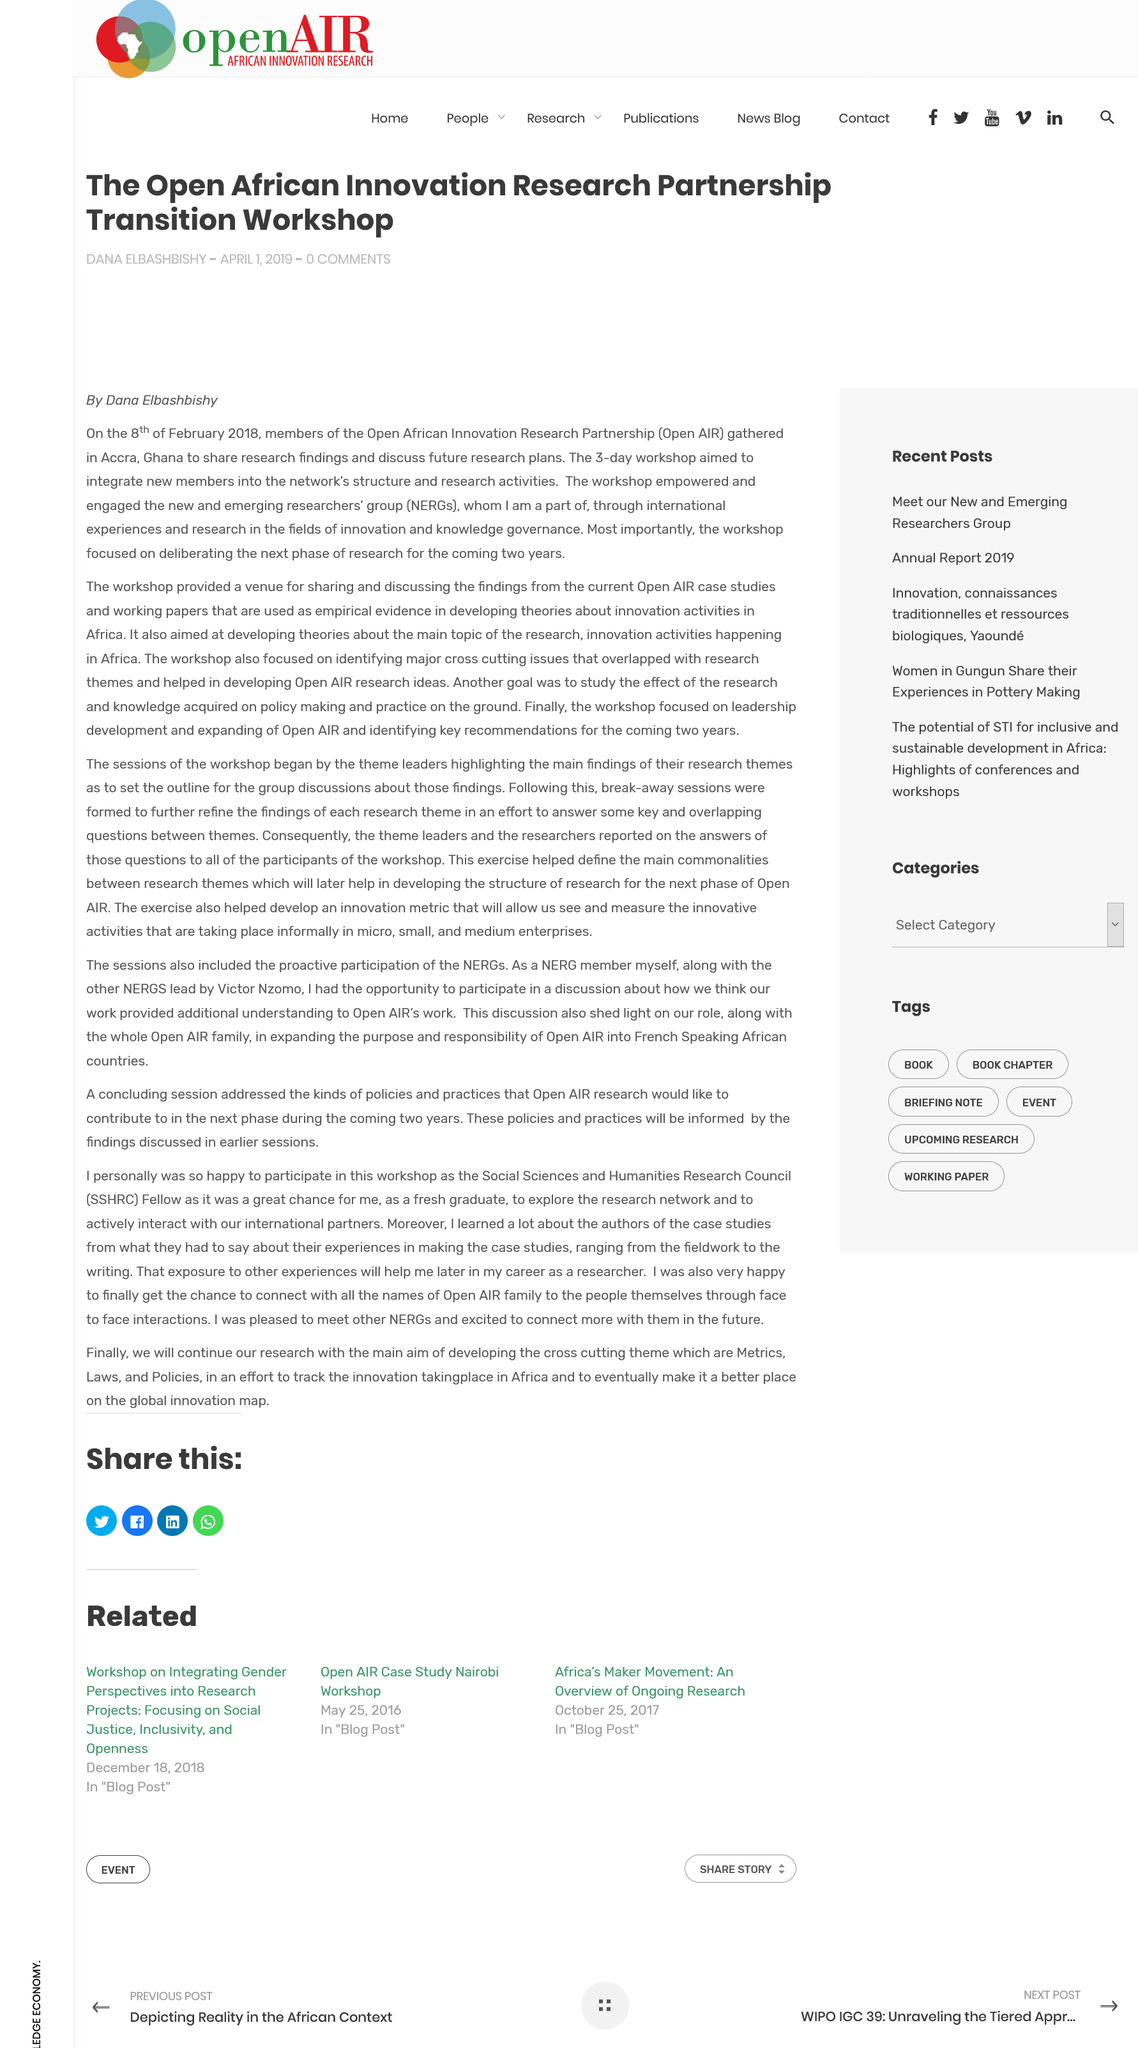Identify some key points in this picture. The members of Open AIR gathered in Accra, Ghana, to share their research findings. Open AIR stands for the Open African Innovation Research Partnership, which is an acronym that represents a collaborative effort aimed at advancing innovation research in Africa. Open AIR conducts research in the fields of innovation and knowledge governance. 